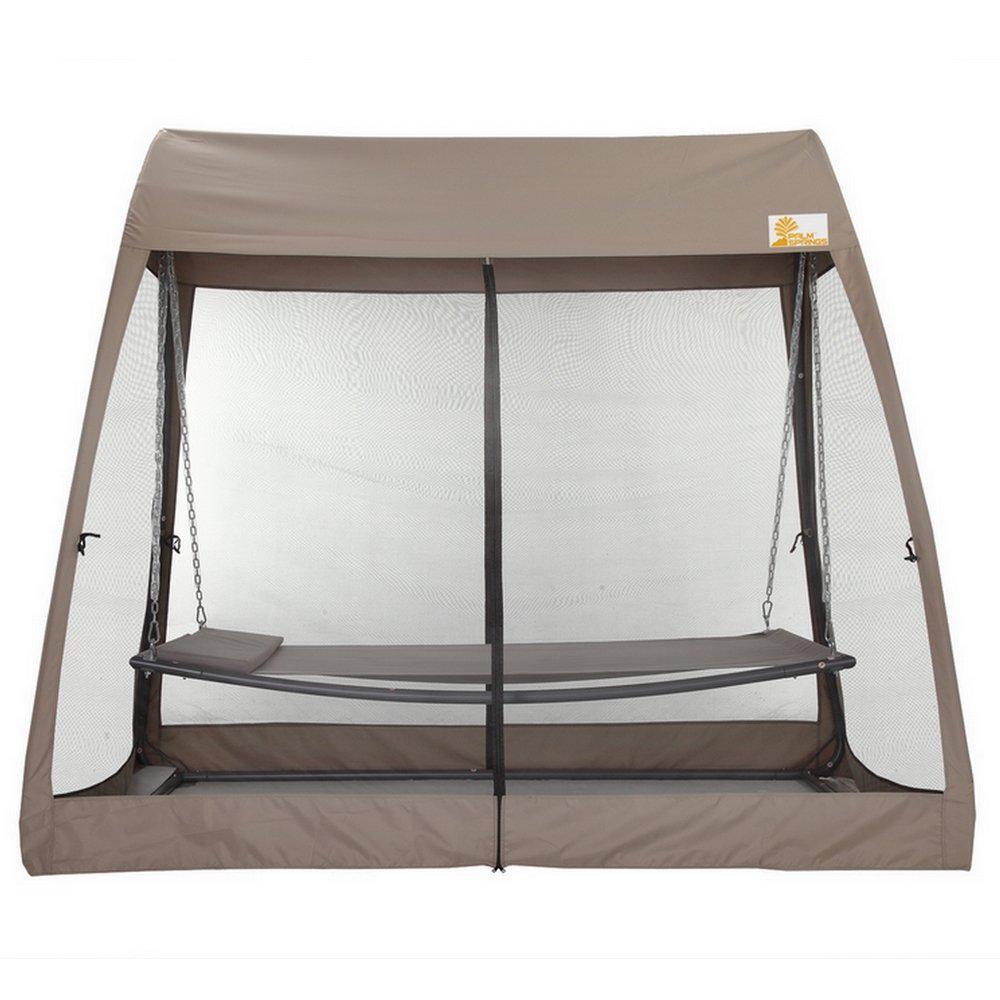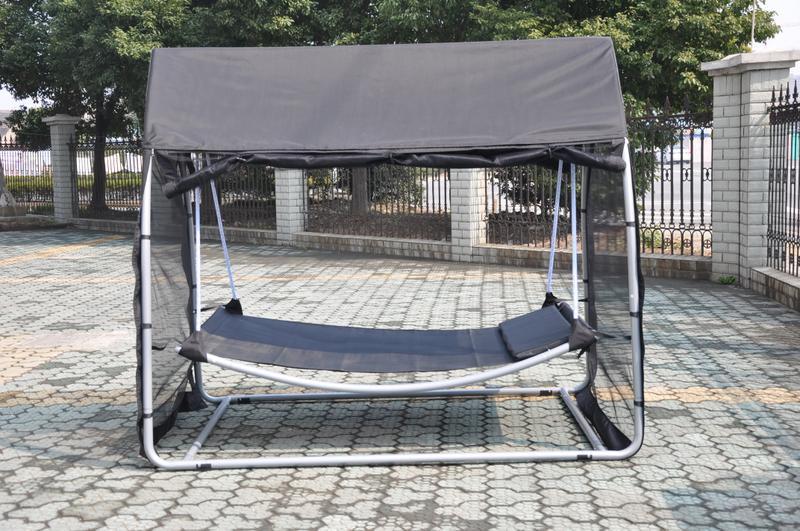The first image is the image on the left, the second image is the image on the right. Examine the images to the left and right. Is the description "The structure in one of the images is standing upon a tiled floor." accurate? Answer yes or no. Yes. The first image is the image on the left, the second image is the image on the right. Evaluate the accuracy of this statement regarding the images: "Both tents are shown without a background.". Is it true? Answer yes or no. No. 